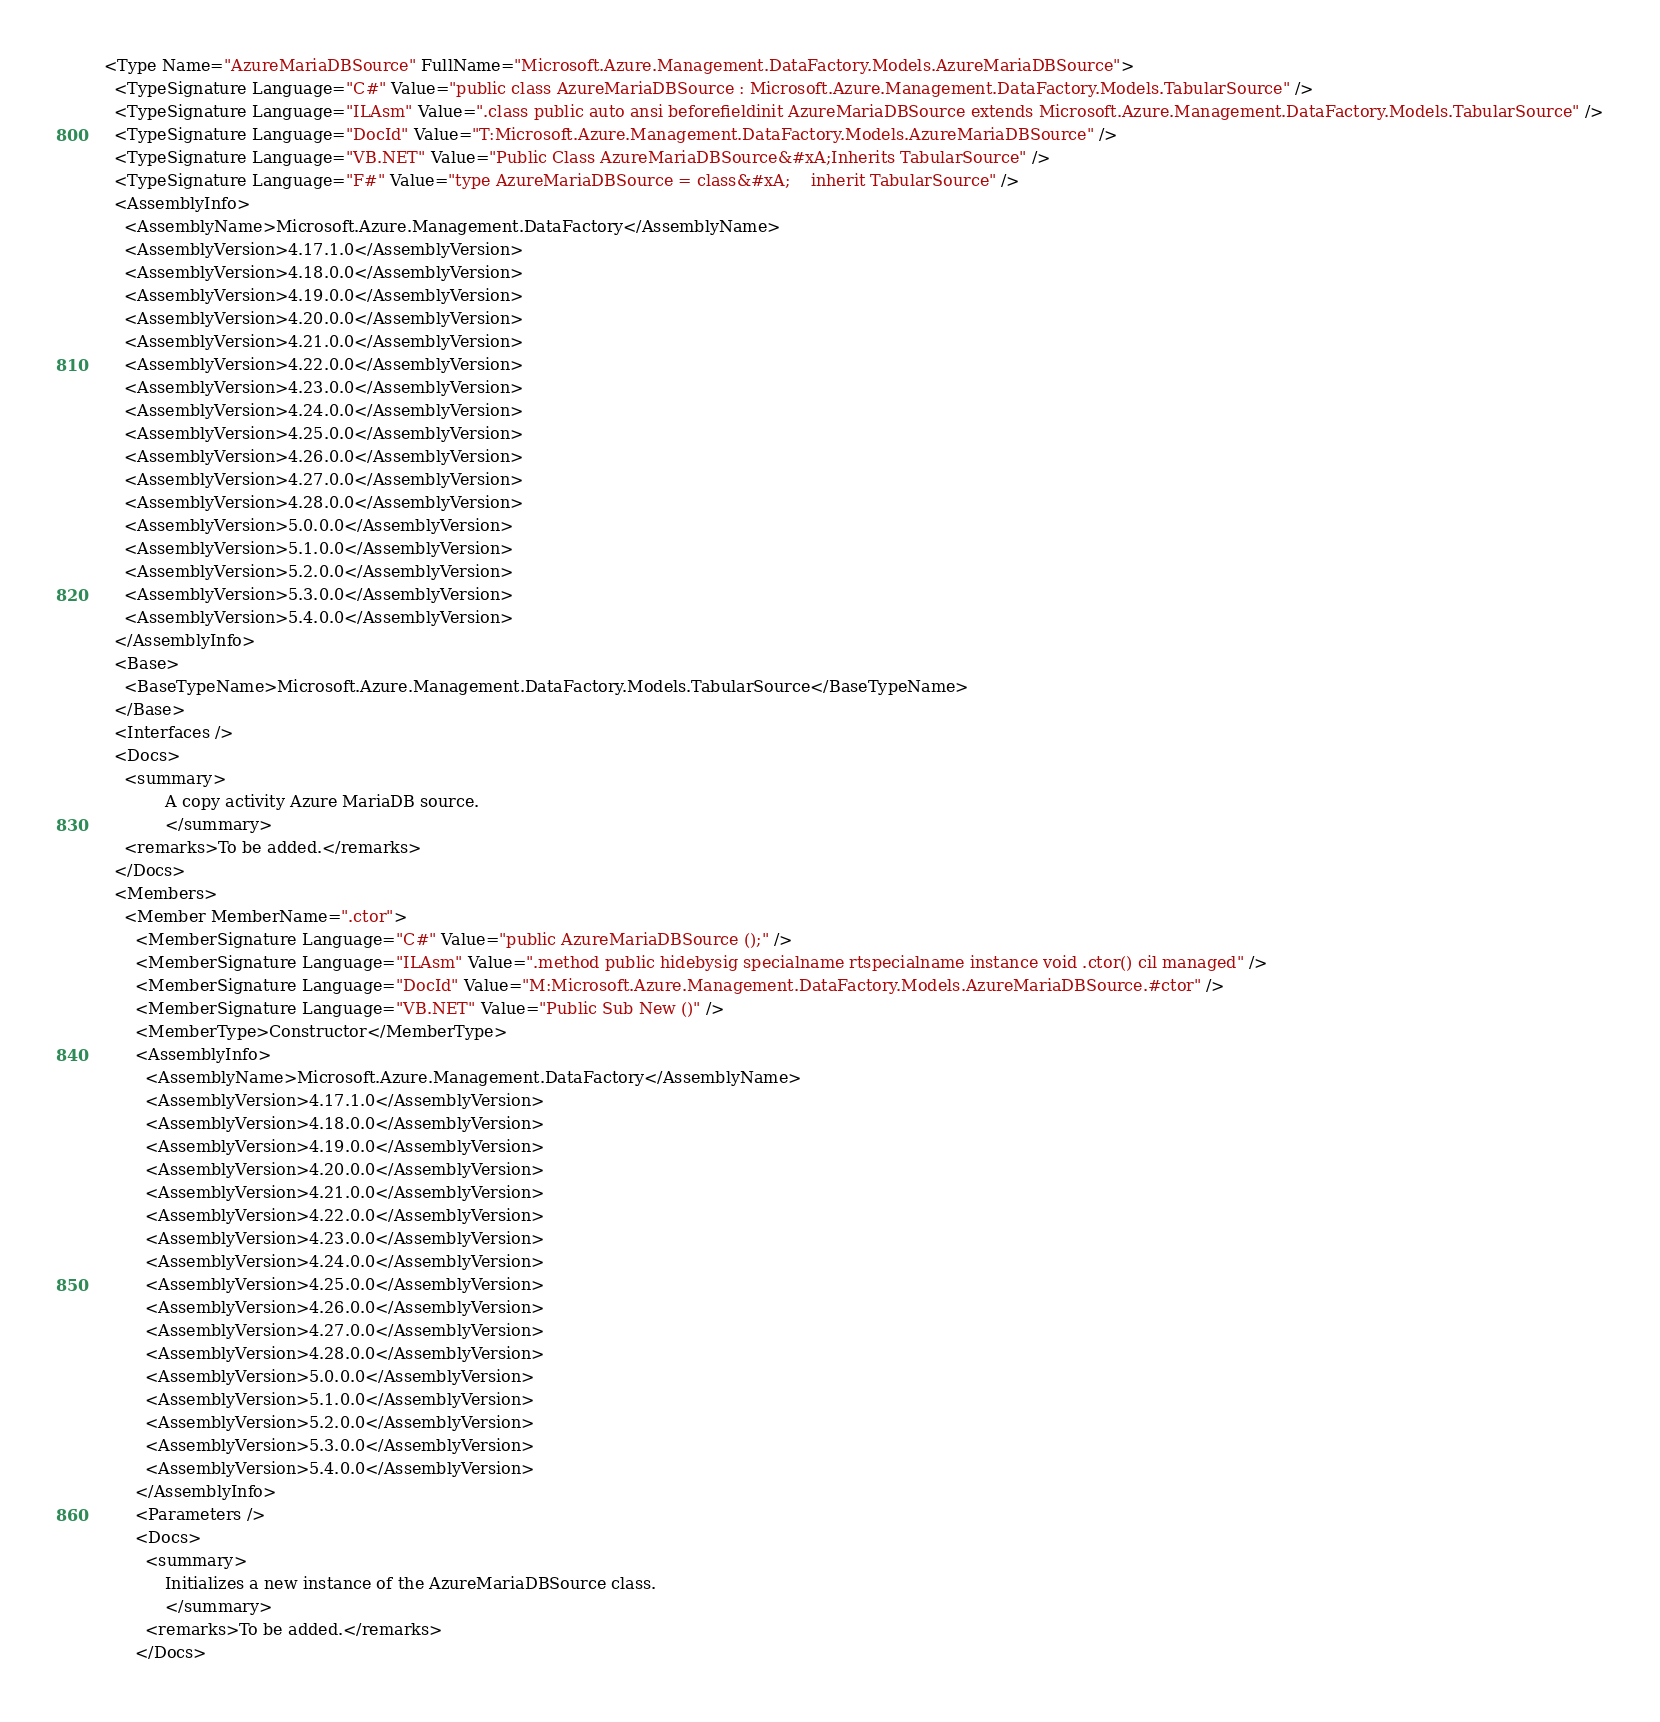<code> <loc_0><loc_0><loc_500><loc_500><_XML_><Type Name="AzureMariaDBSource" FullName="Microsoft.Azure.Management.DataFactory.Models.AzureMariaDBSource">
  <TypeSignature Language="C#" Value="public class AzureMariaDBSource : Microsoft.Azure.Management.DataFactory.Models.TabularSource" />
  <TypeSignature Language="ILAsm" Value=".class public auto ansi beforefieldinit AzureMariaDBSource extends Microsoft.Azure.Management.DataFactory.Models.TabularSource" />
  <TypeSignature Language="DocId" Value="T:Microsoft.Azure.Management.DataFactory.Models.AzureMariaDBSource" />
  <TypeSignature Language="VB.NET" Value="Public Class AzureMariaDBSource&#xA;Inherits TabularSource" />
  <TypeSignature Language="F#" Value="type AzureMariaDBSource = class&#xA;    inherit TabularSource" />
  <AssemblyInfo>
    <AssemblyName>Microsoft.Azure.Management.DataFactory</AssemblyName>
    <AssemblyVersion>4.17.1.0</AssemblyVersion>
    <AssemblyVersion>4.18.0.0</AssemblyVersion>
    <AssemblyVersion>4.19.0.0</AssemblyVersion>
    <AssemblyVersion>4.20.0.0</AssemblyVersion>
    <AssemblyVersion>4.21.0.0</AssemblyVersion>
    <AssemblyVersion>4.22.0.0</AssemblyVersion>
    <AssemblyVersion>4.23.0.0</AssemblyVersion>
    <AssemblyVersion>4.24.0.0</AssemblyVersion>
    <AssemblyVersion>4.25.0.0</AssemblyVersion>
    <AssemblyVersion>4.26.0.0</AssemblyVersion>
    <AssemblyVersion>4.27.0.0</AssemblyVersion>
    <AssemblyVersion>4.28.0.0</AssemblyVersion>
    <AssemblyVersion>5.0.0.0</AssemblyVersion>
    <AssemblyVersion>5.1.0.0</AssemblyVersion>
    <AssemblyVersion>5.2.0.0</AssemblyVersion>
    <AssemblyVersion>5.3.0.0</AssemblyVersion>
    <AssemblyVersion>5.4.0.0</AssemblyVersion>
  </AssemblyInfo>
  <Base>
    <BaseTypeName>Microsoft.Azure.Management.DataFactory.Models.TabularSource</BaseTypeName>
  </Base>
  <Interfaces />
  <Docs>
    <summary>
            A copy activity Azure MariaDB source.
            </summary>
    <remarks>To be added.</remarks>
  </Docs>
  <Members>
    <Member MemberName=".ctor">
      <MemberSignature Language="C#" Value="public AzureMariaDBSource ();" />
      <MemberSignature Language="ILAsm" Value=".method public hidebysig specialname rtspecialname instance void .ctor() cil managed" />
      <MemberSignature Language="DocId" Value="M:Microsoft.Azure.Management.DataFactory.Models.AzureMariaDBSource.#ctor" />
      <MemberSignature Language="VB.NET" Value="Public Sub New ()" />
      <MemberType>Constructor</MemberType>
      <AssemblyInfo>
        <AssemblyName>Microsoft.Azure.Management.DataFactory</AssemblyName>
        <AssemblyVersion>4.17.1.0</AssemblyVersion>
        <AssemblyVersion>4.18.0.0</AssemblyVersion>
        <AssemblyVersion>4.19.0.0</AssemblyVersion>
        <AssemblyVersion>4.20.0.0</AssemblyVersion>
        <AssemblyVersion>4.21.0.0</AssemblyVersion>
        <AssemblyVersion>4.22.0.0</AssemblyVersion>
        <AssemblyVersion>4.23.0.0</AssemblyVersion>
        <AssemblyVersion>4.24.0.0</AssemblyVersion>
        <AssemblyVersion>4.25.0.0</AssemblyVersion>
        <AssemblyVersion>4.26.0.0</AssemblyVersion>
        <AssemblyVersion>4.27.0.0</AssemblyVersion>
        <AssemblyVersion>4.28.0.0</AssemblyVersion>
        <AssemblyVersion>5.0.0.0</AssemblyVersion>
        <AssemblyVersion>5.1.0.0</AssemblyVersion>
        <AssemblyVersion>5.2.0.0</AssemblyVersion>
        <AssemblyVersion>5.3.0.0</AssemblyVersion>
        <AssemblyVersion>5.4.0.0</AssemblyVersion>
      </AssemblyInfo>
      <Parameters />
      <Docs>
        <summary>
            Initializes a new instance of the AzureMariaDBSource class.
            </summary>
        <remarks>To be added.</remarks>
      </Docs></code> 